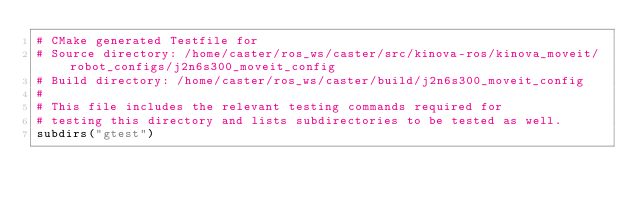<code> <loc_0><loc_0><loc_500><loc_500><_CMake_># CMake generated Testfile for 
# Source directory: /home/caster/ros_ws/caster/src/kinova-ros/kinova_moveit/robot_configs/j2n6s300_moveit_config
# Build directory: /home/caster/ros_ws/caster/build/j2n6s300_moveit_config
# 
# This file includes the relevant testing commands required for 
# testing this directory and lists subdirectories to be tested as well.
subdirs("gtest")
</code> 